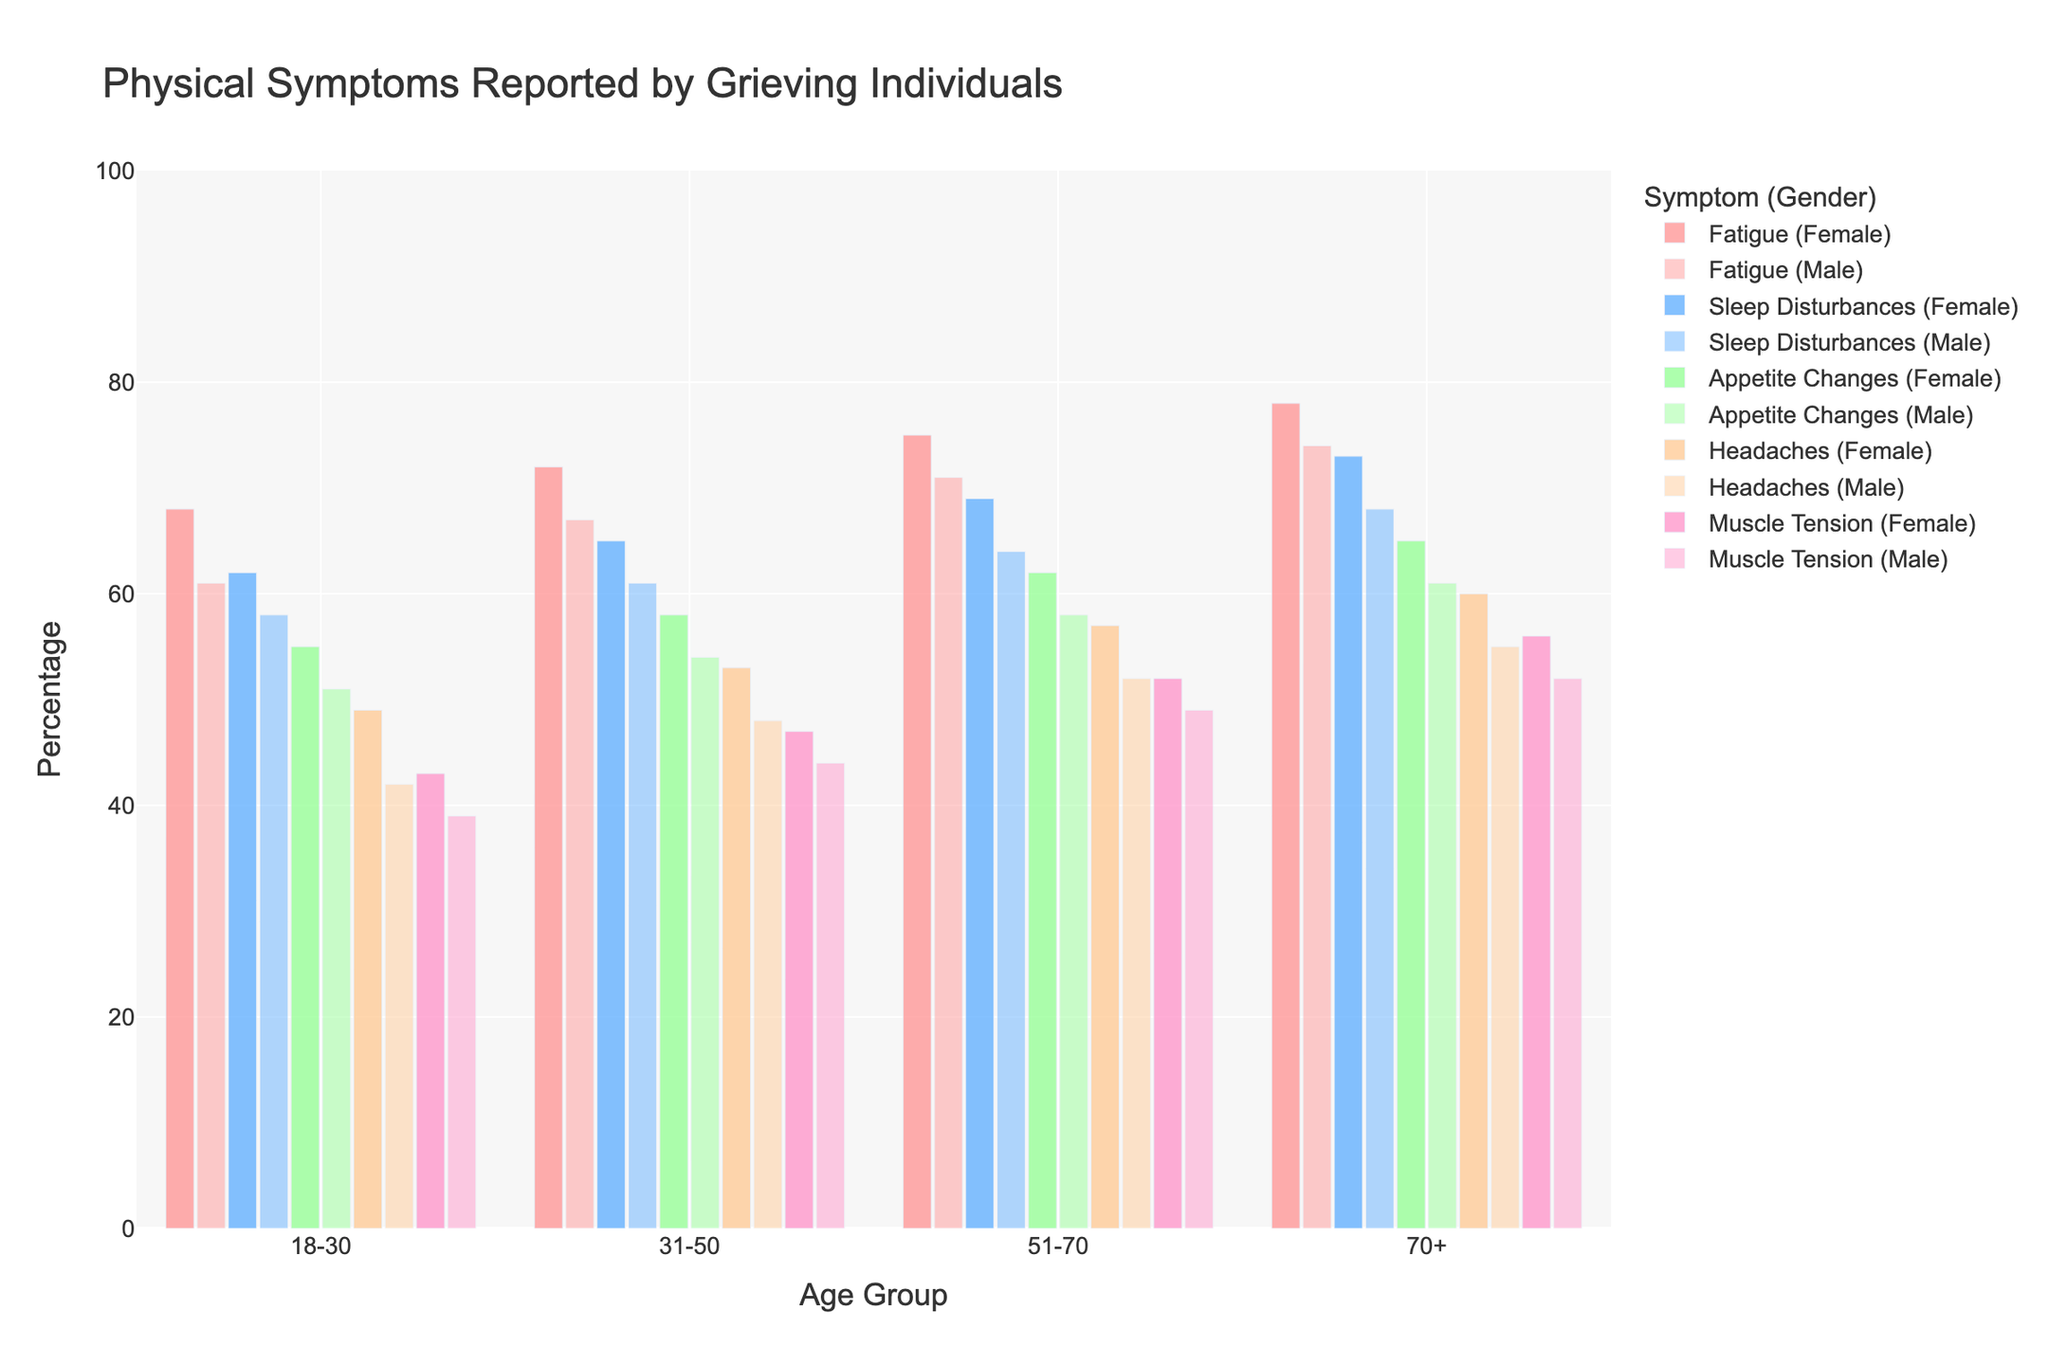What is the most commonly reported symptom for females aged 51-70? Look at the 51-70 age group for females and identify which symptom has the highest percentage bar. Fatigue has the highest percentage at 75%.
Answer: Fatigue What is the difference in the reported percentage of sleep disturbances between males and females aged 18-30? Identify the percentage bars for sleep disturbances for both males and females aged 18-30. Subtract the male percentage (58%) from the female percentage (62%).
Answer: 4% Which gender reports a higher percentage of headaches in the 70+ age group? Compare the percentage bars for headaches between males and females in the 70+ age group. Females report 60%, while males report 55%.
Answer: Females In which age group do males and females show the closest percentage reporting muscle tension, and what is the percentage difference? Compare the muscle tension percentages for each age group between males and females. Age group 31-50 shows the smallest difference with 47% for females and 44% for males. The difference is 3%.
Answer: 31-50, 3% Between ages 31-50, which symptom shows the least percentage difference between genders? For each symptom in the 31-50 age group, calculate the difference between male and female percentages. Appetite Changes show the least difference: females 58%, males 54%, making a 4% difference.
Answer: Appetite Changes What is the average reported percentage of fatigue in all age groups for males? Identify the fatigue percentages for males in all age groups (61%, 67%, 71%, 74%). Sum these values (61 + 67 + 71 + 74 = 273) and divide by the number of age groups (4).
Answer: 68.25% How does the percentage of appetite changes in males aged 51-70 compare to those in females aged 51-70? Compare the appetite changes percentages: 62% for females and 58% for males, showing that females report a 4% higher percentage.
Answer: Females report 4% higher Which age group reports the highest percentage of sleep disturbances overall? Sum the sleep disturbances percentages for both genders within each age group and compare. The 70+ age group has the highest percentages: females 73% and males 68%, summed as 141%.
Answer: 70+ What is the sum of the reported percentages of headaches for females across all age groups? Add the headache percentages for females in each age group: 49% (18-30), 53% (31-50), 57% (51-70), and 60% (70+). Sum these values (49 + 53 + 57 + 60 = 219).
Answer: 219% Which symptom shows the largest increase in reported percentage from the 18-30 age group to the 70+ age group for females? For each symptom, calculate the difference between the 70+ and 18-30 age groups. Fatigue increases from 68% to 78%, a 10% increase, the largest among the symptoms.
Answer: Fatigue 